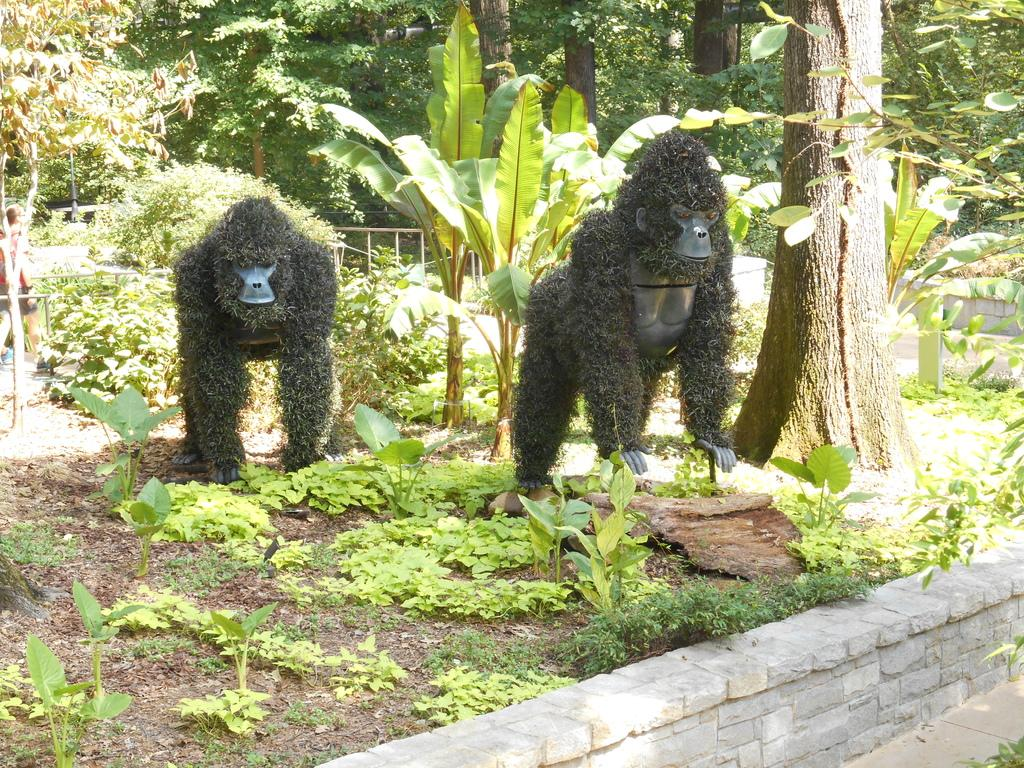What type of toys are present in the image? There are two chimpanzee toys in the image. What else can be seen in the image besides the toys? There are plants and trees in the image. What is the background of the image? There is a wall in the image. What type of brake system can be seen on the chimpanzee toys in the image? There is no brake system present on the chimpanzee toys in the image, as they are toys and not vehicles. 